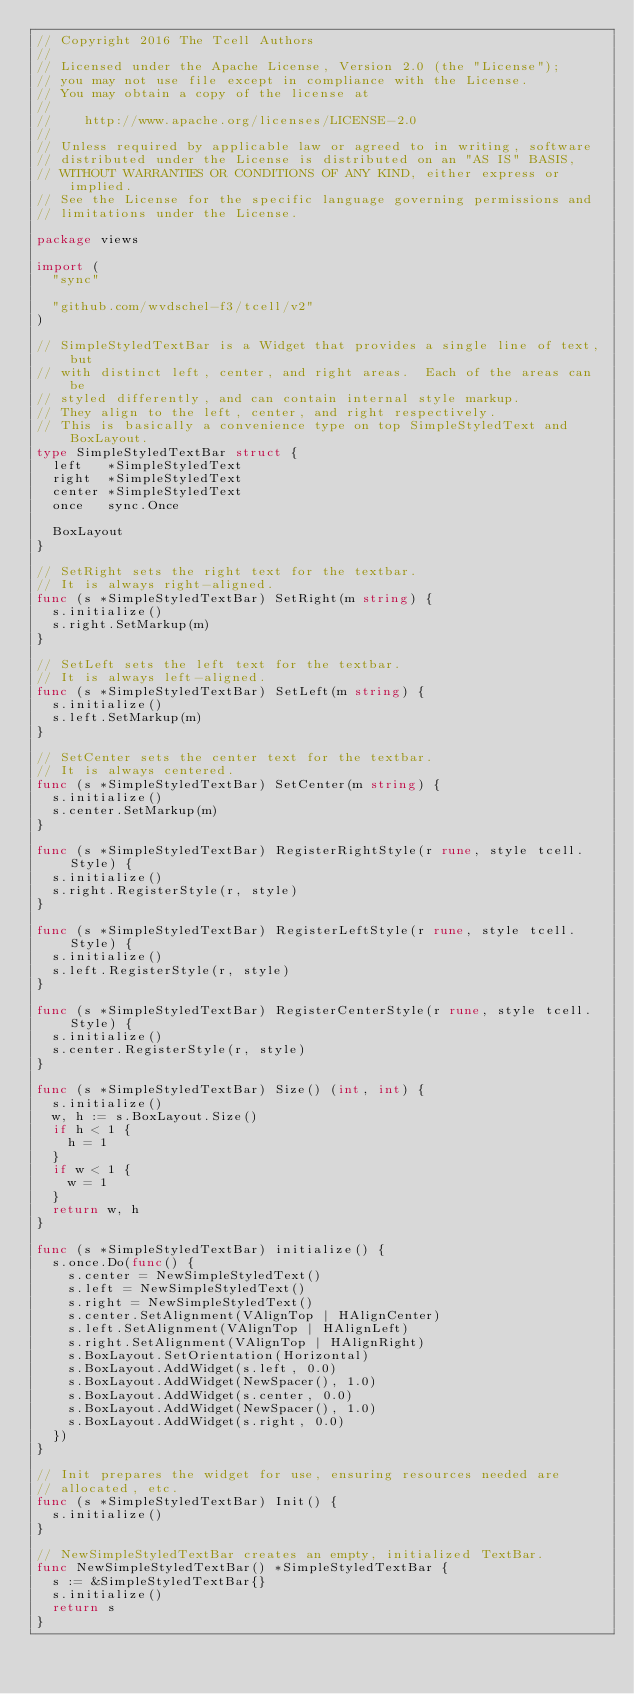<code> <loc_0><loc_0><loc_500><loc_500><_Go_>// Copyright 2016 The Tcell Authors
//
// Licensed under the Apache License, Version 2.0 (the "License");
// you may not use file except in compliance with the License.
// You may obtain a copy of the license at
//
//    http://www.apache.org/licenses/LICENSE-2.0
//
// Unless required by applicable law or agreed to in writing, software
// distributed under the License is distributed on an "AS IS" BASIS,
// WITHOUT WARRANTIES OR CONDITIONS OF ANY KIND, either express or implied.
// See the License for the specific language governing permissions and
// limitations under the License.

package views

import (
	"sync"

	"github.com/wvdschel-f3/tcell/v2"
)

// SimpleStyledTextBar is a Widget that provides a single line of text, but
// with distinct left, center, and right areas.  Each of the areas can be
// styled differently, and can contain internal style markup.
// They align to the left, center, and right respectively.
// This is basically a convenience type on top SimpleStyledText and BoxLayout.
type SimpleStyledTextBar struct {
	left   *SimpleStyledText
	right  *SimpleStyledText
	center *SimpleStyledText
	once   sync.Once

	BoxLayout
}

// SetRight sets the right text for the textbar.
// It is always right-aligned.
func (s *SimpleStyledTextBar) SetRight(m string) {
	s.initialize()
	s.right.SetMarkup(m)
}

// SetLeft sets the left text for the textbar.
// It is always left-aligned.
func (s *SimpleStyledTextBar) SetLeft(m string) {
	s.initialize()
	s.left.SetMarkup(m)
}

// SetCenter sets the center text for the textbar.
// It is always centered.
func (s *SimpleStyledTextBar) SetCenter(m string) {
	s.initialize()
	s.center.SetMarkup(m)
}

func (s *SimpleStyledTextBar) RegisterRightStyle(r rune, style tcell.Style) {
	s.initialize()
	s.right.RegisterStyle(r, style)
}

func (s *SimpleStyledTextBar) RegisterLeftStyle(r rune, style tcell.Style) {
	s.initialize()
	s.left.RegisterStyle(r, style)
}

func (s *SimpleStyledTextBar) RegisterCenterStyle(r rune, style tcell.Style) {
	s.initialize()
	s.center.RegisterStyle(r, style)
}

func (s *SimpleStyledTextBar) Size() (int, int) {
	s.initialize()
	w, h := s.BoxLayout.Size()
	if h < 1 {
		h = 1
	}
	if w < 1 {
		w = 1
	}
	return w, h
}

func (s *SimpleStyledTextBar) initialize() {
	s.once.Do(func() {
		s.center = NewSimpleStyledText()
		s.left = NewSimpleStyledText()
		s.right = NewSimpleStyledText()
		s.center.SetAlignment(VAlignTop | HAlignCenter)
		s.left.SetAlignment(VAlignTop | HAlignLeft)
		s.right.SetAlignment(VAlignTop | HAlignRight)
		s.BoxLayout.SetOrientation(Horizontal)
		s.BoxLayout.AddWidget(s.left, 0.0)
		s.BoxLayout.AddWidget(NewSpacer(), 1.0)
		s.BoxLayout.AddWidget(s.center, 0.0)
		s.BoxLayout.AddWidget(NewSpacer(), 1.0)
		s.BoxLayout.AddWidget(s.right, 0.0)
	})
}

// Init prepares the widget for use, ensuring resources needed are
// allocated, etc.
func (s *SimpleStyledTextBar) Init() {
	s.initialize()
}

// NewSimpleStyledTextBar creates an empty, initialized TextBar.
func NewSimpleStyledTextBar() *SimpleStyledTextBar {
	s := &SimpleStyledTextBar{}
	s.initialize()
	return s
}
</code> 